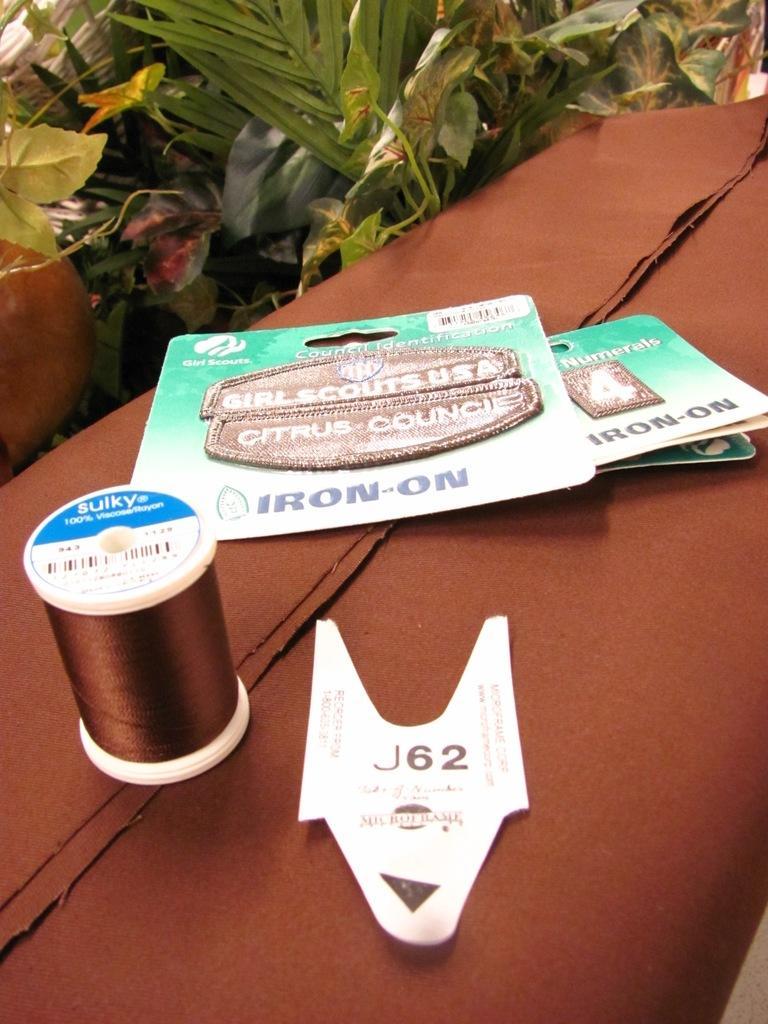Could you give a brief overview of what you see in this image? In the picture there is a brown cloth, on the cloth there are some items and the brown thread are kept, behind the cloth there are few plants. 